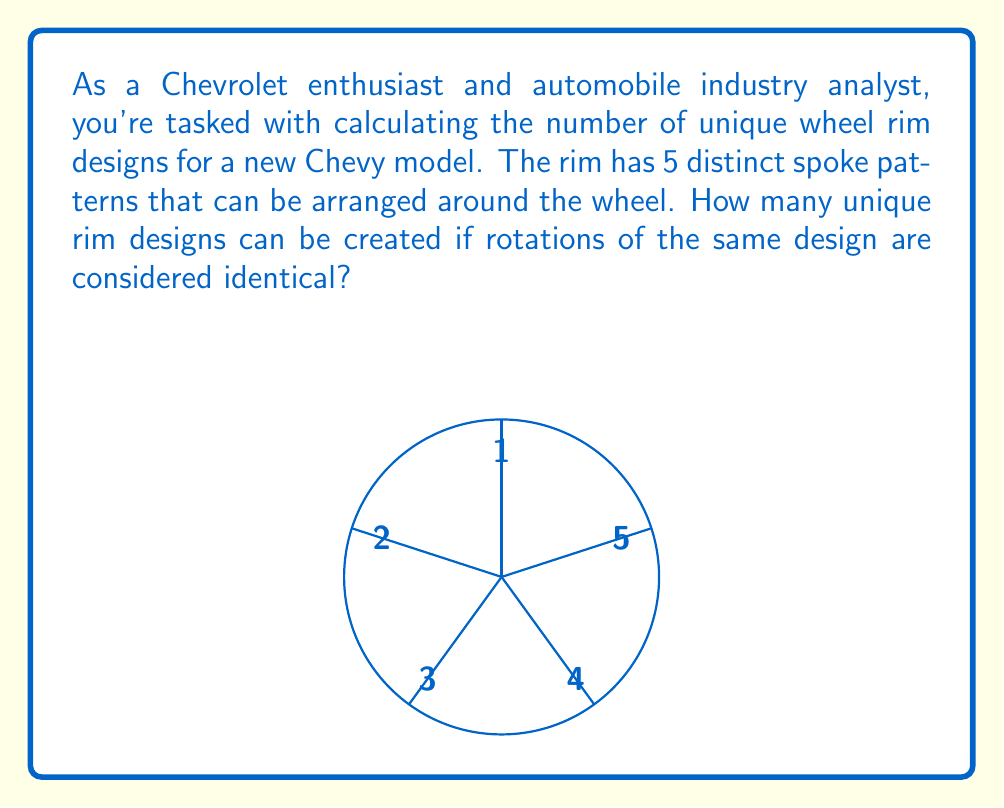Can you solve this math problem? To solve this problem, we can use concepts from group theory, specifically the Orbit-Stabilizer theorem and Burnside's lemma.

1) First, we identify the group acting on our set of rim designs. In this case, it's the cyclic group $C_5$ of rotations of order 5.

2) The total number of possible arrangements (without considering rotations as identical) is $5! = 120$.

3) We need to find the number of arrangements fixed by each rotation in $C_5$:
   - Identity rotation (0°): Fixes all 120 arrangements
   - 72° rotation: Fixes only arrangements with all spokes identical, so 5 arrangements
   - 144° rotation: Also fixes 5 arrangements
   - 216° rotation: Also fixes 5 arrangements
   - 288° rotation: Also fixes 5 arrangements

4) Applying Burnside's lemma:
   $$ N = \frac{1}{|G|} \sum_{g \in G} |Fix(g)| $$
   where $N$ is the number of unique orbits (unique designs), $|G|$ is the order of the group, and $|Fix(g)|$ is the number of elements fixed by group element $g$.

5) Substituting our values:
   $$ N = \frac{1}{5} (120 + 5 + 5 + 5 + 5) = \frac{140}{5} = 28 $$

Thus, there are 28 unique wheel rim designs when rotations are considered identical.
Answer: 28 unique designs 